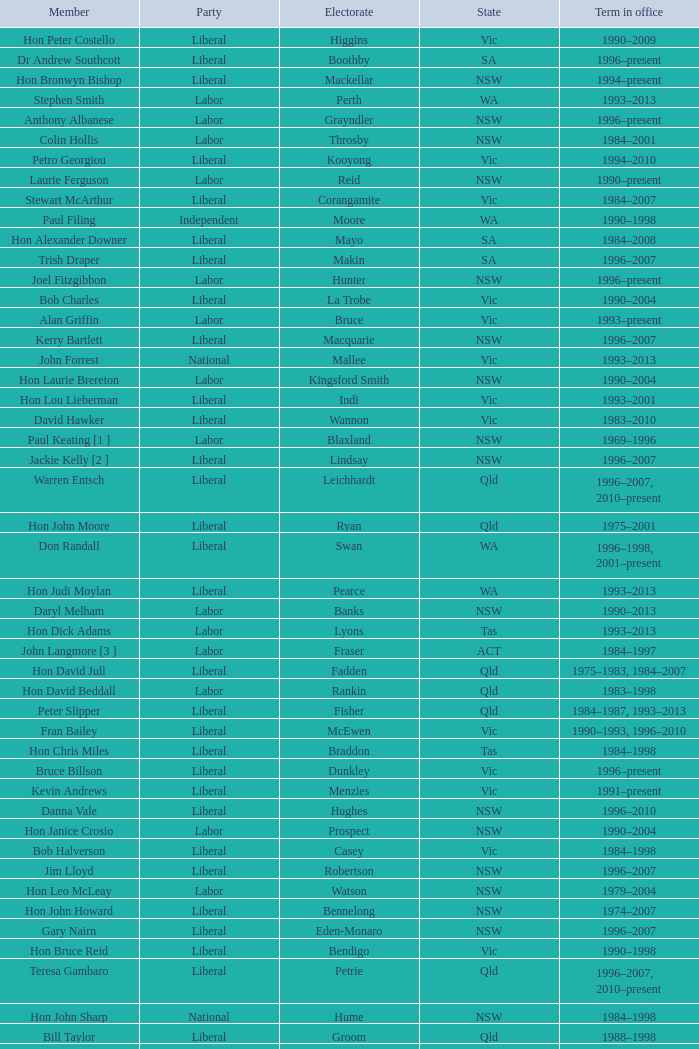What state did Hon David Beddall belong to? Qld. Could you help me parse every detail presented in this table? {'header': ['Member', 'Party', 'Electorate', 'State', 'Term in office'], 'rows': [['Hon Peter Costello', 'Liberal', 'Higgins', 'Vic', '1990–2009'], ['Dr Andrew Southcott', 'Liberal', 'Boothby', 'SA', '1996–present'], ['Hon Bronwyn Bishop', 'Liberal', 'Mackellar', 'NSW', '1994–present'], ['Stephen Smith', 'Labor', 'Perth', 'WA', '1993–2013'], ['Anthony Albanese', 'Labor', 'Grayndler', 'NSW', '1996–present'], ['Colin Hollis', 'Labor', 'Throsby', 'NSW', '1984–2001'], ['Petro Georgiou', 'Liberal', 'Kooyong', 'Vic', '1994–2010'], ['Laurie Ferguson', 'Labor', 'Reid', 'NSW', '1990–present'], ['Stewart McArthur', 'Liberal', 'Corangamite', 'Vic', '1984–2007'], ['Paul Filing', 'Independent', 'Moore', 'WA', '1990–1998'], ['Hon Alexander Downer', 'Liberal', 'Mayo', 'SA', '1984–2008'], ['Trish Draper', 'Liberal', 'Makin', 'SA', '1996–2007'], ['Joel Fitzgibbon', 'Labor', 'Hunter', 'NSW', '1996–present'], ['Bob Charles', 'Liberal', 'La Trobe', 'Vic', '1990–2004'], ['Alan Griffin', 'Labor', 'Bruce', 'Vic', '1993–present'], ['Kerry Bartlett', 'Liberal', 'Macquarie', 'NSW', '1996–2007'], ['John Forrest', 'National', 'Mallee', 'Vic', '1993–2013'], ['Hon Laurie Brereton', 'Labor', 'Kingsford Smith', 'NSW', '1990–2004'], ['Hon Lou Lieberman', 'Liberal', 'Indi', 'Vic', '1993–2001'], ['David Hawker', 'Liberal', 'Wannon', 'Vic', '1983–2010'], ['Paul Keating [1 ]', 'Labor', 'Blaxland', 'NSW', '1969–1996'], ['Jackie Kelly [2 ]', 'Liberal', 'Lindsay', 'NSW', '1996–2007'], ['Warren Entsch', 'Liberal', 'Leichhardt', 'Qld', '1996–2007, 2010–present'], ['Hon John Moore', 'Liberal', 'Ryan', 'Qld', '1975–2001'], ['Don Randall', 'Liberal', 'Swan', 'WA', '1996–1998, 2001–present'], ['Hon Judi Moylan', 'Liberal', 'Pearce', 'WA', '1993–2013'], ['Daryl Melham', 'Labor', 'Banks', 'NSW', '1990–2013'], ['Hon Dick Adams', 'Labor', 'Lyons', 'Tas', '1993–2013'], ['John Langmore [3 ]', 'Labor', 'Fraser', 'ACT', '1984–1997'], ['Hon David Jull', 'Liberal', 'Fadden', 'Qld', '1975–1983, 1984–2007'], ['Hon David Beddall', 'Labor', 'Rankin', 'Qld', '1983–1998'], ['Peter Slipper', 'Liberal', 'Fisher', 'Qld', '1984–1987, 1993–2013'], ['Fran Bailey', 'Liberal', 'McEwen', 'Vic', '1990–1993, 1996–2010'], ['Hon Chris Miles', 'Liberal', 'Braddon', 'Tas', '1984–1998'], ['Bruce Billson', 'Liberal', 'Dunkley', 'Vic', '1996–present'], ['Kevin Andrews', 'Liberal', 'Menzies', 'Vic', '1991–present'], ['Danna Vale', 'Liberal', 'Hughes', 'NSW', '1996–2010'], ['Hon Janice Crosio', 'Labor', 'Prospect', 'NSW', '1990–2004'], ['Bob Halverson', 'Liberal', 'Casey', 'Vic', '1984–1998'], ['Jim Lloyd', 'Liberal', 'Robertson', 'NSW', '1996–2007'], ['Hon Leo McLeay', 'Labor', 'Watson', 'NSW', '1979–2004'], ['Hon John Howard', 'Liberal', 'Bennelong', 'NSW', '1974–2007'], ['Gary Nairn', 'Liberal', 'Eden-Monaro', 'NSW', '1996–2007'], ['Hon Bruce Reid', 'Liberal', 'Bendigo', 'Vic', '1990–1998'], ['Teresa Gambaro', 'Liberal', 'Petrie', 'Qld', '1996–2007, 2010–present'], ['Hon John Sharp', 'National', 'Hume', 'NSW', '1984–1998'], ['Bill Taylor', 'Liberal', 'Groom', 'Qld', '1988–1998'], ['Steve Dargavel [3 ]', 'Labor', 'Fraser', 'ACT', '1997–1998'], ['Robert McClelland', 'Labor', 'Barton', 'NSW', '1996–2013'], ['Kelvin Thomson', 'Labor', 'Wills', 'Vic', '1996–present'], ['Christopher Pyne', 'Liberal', 'Sturt', 'SA', '1993–present'], ['Alan Cadman', 'Liberal', 'Mitchell', 'NSW', '1974–2007'], ['Bob Baldwin', 'Liberal', 'Paterson', 'NSW', '1996–present'], ['Hon Geoff Prosser', 'Liberal', 'Forrest', 'WA', '1987–2007'], ['Richard Evans', 'Liberal', 'Cowan', 'WA', '1993–1998'], ['Hon Michael Lee', 'Labor', 'Dobell', 'NSW', '1984–2001'], ['Michael Cobb', 'National', 'Parkes', 'NSW', '1984–1998'], ['Hon Dr David Kemp', 'Liberal', 'Goldstein', 'Vic', '1990–2004'], ['Bob Sercombe', 'Labor', 'Maribyrnong', 'Vic', '1996–2007'], ['John Fahey', 'Liberal', 'Macarthur', 'NSW', '1996–2001'], ['Hon Gareth Evans', 'Labor', 'Holt', 'Vic', '1996–1999'], ['Hon Warwick Smith', 'Liberal', 'Bass', 'Tas', '1984–1993, 1996–1998'], ['Paul Zammit', 'Liberal/Independent [6 ]', 'Lowe', 'NSW', '1996–1998'], ['Mark Latham', 'Labor', 'Werriwa', 'NSW', '1994–2005'], ['Peter Andren', 'Independent', 'Calare', 'NSW', '1996–2007'], ['Harry Quick', 'Labor', 'Franklin', 'Tas', '1993–2007'], ['Annette Ellis', 'Labor', 'Namadgi', 'ACT', '1996–2010'], ['Peter Nugent', 'Liberal', 'Aston', 'Vic', '1990–2001'], ['Joe Hockey', 'Liberal', 'North Sydney', 'NSW', '1996–present'], ['Martin Ferguson', 'Labor', 'Batman', 'Vic', '1996–2013'], ['Hon Duncan Kerr', 'Labor', 'Denison', 'Tas', '1987–2010'], ['Greg Wilton', 'Labor', 'Isaacs', 'Vic', '1996–2000'], ['Hon Ian McLachlan', 'Liberal', 'Barker', 'SA', '1990–1998'], ['Wilson Tuckey', 'Liberal', "O'Connor", 'WA', '1980–2010'], ['Ricky Johnston', 'Liberal', 'Canning', 'WA', '1996–1998'], ['Hon Bob Katter', 'National', 'Kennedy', 'Qld', '1993–present'], ['Phil Barresi', 'Liberal', 'Deakin', 'Vic', '1996–2007'], ['Hon Bob Brown', 'Labor', 'Charlton', 'NSW', '1980–1998'], ['Neil Andrew', 'Liberal', 'Wakefield', 'SA', '1983–2004'], ['Tony Smith', 'Liberal/Independent [7 ]', 'Dickson', 'Qld', '1996–1998'], ['Kathy Sullivan', 'Liberal', 'Moncrieff', 'Qld', '1984–2001'], ['Lindsay Tanner', 'Labor', 'Melbourne', 'Vic', '1993–2010'], ['Nick Dondas', 'CLP', 'Northern Territory', 'NT', '1996–1998'], ['Peter Lindsay', 'Liberal', 'Herbert', 'Qld', '1996–2010'], ["Hon Neil O'Keefe", 'Labor', 'Burke', 'Vic', '1984–2001'], ['Allan Morris', 'Labor', 'Newcastle', 'NSW', '1983–2001'], ['Christine Gallus', 'Liberal', 'Hindmarsh', 'SA', '1990–2004'], ['Paul Marek', 'National', 'Capricornia', 'Qld', '1996–1998'], ['Andrea West', 'Liberal', 'Bowman', 'Qld', '1996–1998'], ['Jenny Macklin', 'Labor', 'Jagajaga', 'Vic', '1996–present'], ['Hon Ralph Willis', 'Labor', 'Gellibrand', 'Vic', '1972–1998'], ['Hon Michael Wooldridge', 'Liberal', 'Casey', 'Vic', '1987–2001'], ['Graeme McDougall', 'Liberal', 'Griffith', 'Qld', '1996–1998'], ['Hon Martyn Evans', 'Labor', 'Bonython', 'SA', '1994–2004'], ['Hon Peter Baldwin', 'Labor', 'Sydney', 'NSW', '1983–1998'], ['Larry Anthony', 'National', 'Richmond', 'NSW', '1996–2004'], ['Susan Jeanes', 'Liberal', 'Kingston', 'SA', '1996–1998'], ['Elizabeth Grace', 'Liberal', 'Lilley', 'Qld', '1996–1998'], ['Rod Sawford', 'Labor', 'Adelaide', 'SA', '1988–2007'], ['Graeme Campbell', 'Independent', 'Kalgoorlie', 'WA', '1980–1998'], ['Hon Roger Price', 'Labor', 'Chifley', 'NSW', '1984–2010'], ['Hon Andrew Theophanous', 'Labor', 'Calwell', 'Vic', '1980–2001'], ['Hon Stephen Martin', 'Labor', 'Cunningham', 'NSW', '1984–2002'], ['Hon Peter McGauran', 'National', 'Gippsland', 'Vic', '1983–2008'], ['John Bradford [5 ]', 'Liberal/ CDP', 'McPherson', 'Qld', '1990–1998'], ['Hon Ian Causley', 'National', 'Page', 'NSW', '1996–2007'], ['Trish Worth', 'Liberal', 'Adelaide', 'SA', '1996–2004'], ['Barry Wakelin', 'Liberal', 'Grey', 'SA', '1993–2007'], ['Ted Grace', 'Labor', 'Fowler', 'NSW', '1984–1998'], ['Eoin Cameron', 'Liberal', 'Stirling', 'WA', '1993–1998'], ['Hon Andrew Thomson', 'Liberal', 'Wentworth', 'NSW', '1995–2001'], ["Gavan O'Connor", 'Labor', 'Corio', 'Vic', '1993–2007'], ['Hon Philip Ruddock', 'Liberal', 'Berowra', 'NSW', '1973–present'], ['Russell Broadbent', 'Liberal', 'McMillan', 'Vic', '1990–1993, 1996–1998 2004–present'], ['Hon Dr Carmen Lawrence', 'Labor', 'Fremantle', 'WA', '1994–2007'], ['Hon Bob McMullan', 'Labor', 'Canberra', 'ACT', '1996–2010'], ['Paul Neville', 'National', 'Hinkler', 'Qld', '1993–2013'], ['Hon Peter Reith', 'Liberal', 'Flinders', 'Vic', '1982–1983, 1984–2001'], ['De-Anne Kelly', 'National', 'Dawson', 'Qld', '1996–2007'], ['Hon Ian Sinclair', 'National', 'New England', 'NSW', '1963–1998'], ['Hon Barry Jones', 'Labor', 'Lalor', 'Vic', '1977–1998'], ['Hon Clyde Holding', 'Labor', 'Melbourne Ports', 'Vic', '1977–1998'], ['Warren Truss', 'National', 'Wide Bay', 'Qld', '1990–present'], ['Joanna Gash', 'Liberal', 'Gilmore', 'NSW', '1996–2013'], ['Hon Daryl Williams', 'Liberal', 'Tangney', 'WA', '1993–2004'], ['Dr Sharman Stone', 'Liberal', 'Murray', 'Vic', '1996–present'], ['Michael Hatton [1 ]', 'Labor', 'Blaxland', 'NSW', '1996–2007'], ['Hon Arch Bevis', 'Labor', 'Brisbane', 'Qld', '1990–2010'], ['Hon John Anderson', 'National', 'Gwydir', 'NSW', '1989–2007'], ['Hon Kim Beazley', 'Labor', 'Brand', 'WA', '1980–2007'], ['Frank Mossfield', 'Labor', 'Greenway', 'NSW', '1996–2004'], ['Mal Brough', 'Liberal', 'Longman', 'Qld', '1996–2007'], ['Alex Somlyay', 'Liberal', 'Fairfax', 'Qld', '1990–2013'], ['Ross Cameron', 'Liberal', 'Parramatta', 'NSW', '1996–2004'], ['Dr Brendan Nelson', 'Liberal', 'Bradfield', 'NSW', '1996–2009'], ['Allan Rocher', 'Independent', 'Curtin', 'WA', '1981–1998'], ['Hon Simon Crean', 'Labor', 'Hotham', 'Vic', '1990–2013'], ['Noel Hicks', 'National', 'Riverina', 'NSW', '1980–1998'], ['Michael Ronaldson', 'Liberal', 'Ballarat', 'Vic', '1990–2001'], ['Hon Tim Fischer', 'National', 'Farrer', 'NSW', '1984–2001'], ['Mark Vaile', 'National', 'Lyne', 'NSW', '1993–2008'], ['Hon Peter Morris', 'Labor', 'Shortland', 'NSW', '1972–1998'], ['Gary Hardgrave', 'Liberal', 'Moreton', 'Qld', '1996–2007'], ['Stephen Mutch', 'Liberal', 'Cook', 'NSW', '1996–1998'], ['Hon Tony Abbott', 'Liberal', 'Warringah', 'NSW', '1994–present'], ['Kay Elson', 'Liberal', 'Forde', 'Qld', '1996–2007'], ['Pauline Hanson [4 ]', 'Independent/ ONP', 'Oxley', 'Qld', '1996–1998'], ['Hon Bruce Scott', 'National', 'Maranoa', 'Qld', '1990–present'], ['Garry Nehl', 'National', 'Cowper', 'NSW', '1984–2001'], ['Harry Jenkins', 'Labor', 'Scullin', 'Vic', '1986–2013']]} 